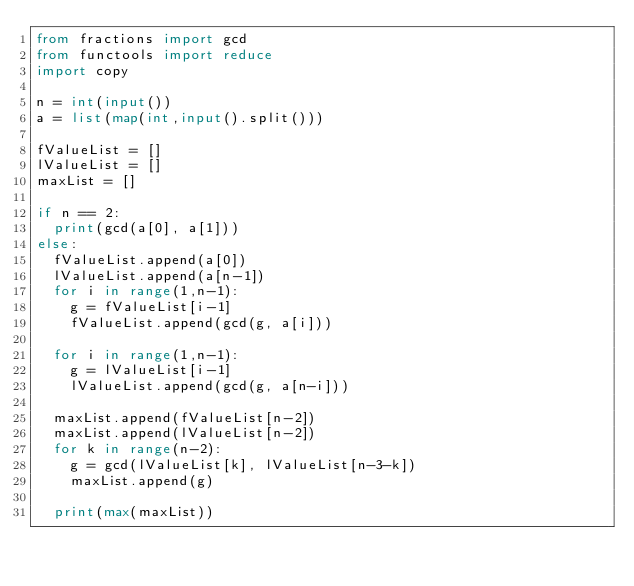Convert code to text. <code><loc_0><loc_0><loc_500><loc_500><_Python_>from fractions import gcd
from functools import reduce
import copy

n = int(input())
a = list(map(int,input().split()))

fValueList = []
lValueList = []
maxList = []

if n == 2:
  print(gcd(a[0], a[1]))
else:
  fValueList.append(a[0])
  lValueList.append(a[n-1])
  for i in range(1,n-1):
    g = fValueList[i-1]
    fValueList.append(gcd(g, a[i]))

  for i in range(1,n-1):
    g = lValueList[i-1]
    lValueList.append(gcd(g, a[n-i]))
  
  maxList.append(fValueList[n-2])
  maxList.append(lValueList[n-2])
  for k in range(n-2):
    g = gcd(lValueList[k], lValueList[n-3-k])
    maxList.append(g)
    
  print(max(maxList))</code> 